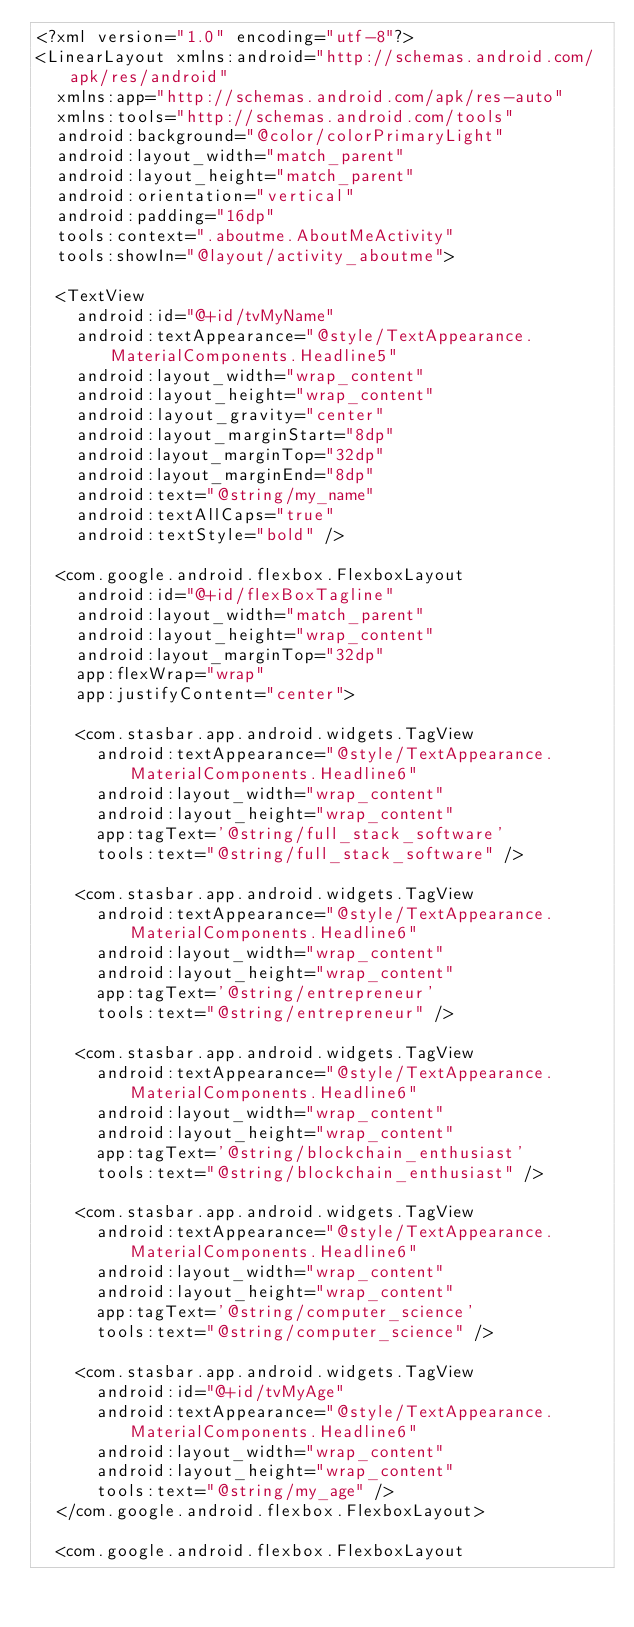Convert code to text. <code><loc_0><loc_0><loc_500><loc_500><_XML_><?xml version="1.0" encoding="utf-8"?>
<LinearLayout xmlns:android="http://schemas.android.com/apk/res/android"
  xmlns:app="http://schemas.android.com/apk/res-auto"
  xmlns:tools="http://schemas.android.com/tools"
  android:background="@color/colorPrimaryLight"
  android:layout_width="match_parent"
  android:layout_height="match_parent"
  android:orientation="vertical"
  android:padding="16dp"
  tools:context=".aboutme.AboutMeActivity"
  tools:showIn="@layout/activity_aboutme">

  <TextView
    android:id="@+id/tvMyName"
    android:textAppearance="@style/TextAppearance.MaterialComponents.Headline5"
    android:layout_width="wrap_content"
    android:layout_height="wrap_content"
    android:layout_gravity="center"
    android:layout_marginStart="8dp"
    android:layout_marginTop="32dp"
    android:layout_marginEnd="8dp"
    android:text="@string/my_name"
    android:textAllCaps="true"
    android:textStyle="bold" />

  <com.google.android.flexbox.FlexboxLayout
    android:id="@+id/flexBoxTagline"
    android:layout_width="match_parent"
    android:layout_height="wrap_content"
    android:layout_marginTop="32dp"
    app:flexWrap="wrap"
    app:justifyContent="center">

    <com.stasbar.app.android.widgets.TagView
      android:textAppearance="@style/TextAppearance.MaterialComponents.Headline6"
      android:layout_width="wrap_content"
      android:layout_height="wrap_content"
      app:tagText='@string/full_stack_software'
      tools:text="@string/full_stack_software" />

    <com.stasbar.app.android.widgets.TagView
      android:textAppearance="@style/TextAppearance.MaterialComponents.Headline6"
      android:layout_width="wrap_content"
      android:layout_height="wrap_content"
      app:tagText='@string/entrepreneur'
      tools:text="@string/entrepreneur" />

    <com.stasbar.app.android.widgets.TagView
      android:textAppearance="@style/TextAppearance.MaterialComponents.Headline6"
      android:layout_width="wrap_content"
      android:layout_height="wrap_content"
      app:tagText='@string/blockchain_enthusiast'
      tools:text="@string/blockchain_enthusiast" />

    <com.stasbar.app.android.widgets.TagView
      android:textAppearance="@style/TextAppearance.MaterialComponents.Headline6"
      android:layout_width="wrap_content"
      android:layout_height="wrap_content"
      app:tagText='@string/computer_science'
      tools:text="@string/computer_science" />

    <com.stasbar.app.android.widgets.TagView
      android:id="@+id/tvMyAge"
      android:textAppearance="@style/TextAppearance.MaterialComponents.Headline6"
      android:layout_width="wrap_content"
      android:layout_height="wrap_content"
      tools:text="@string/my_age" />
  </com.google.android.flexbox.FlexboxLayout>

  <com.google.android.flexbox.FlexboxLayout</code> 